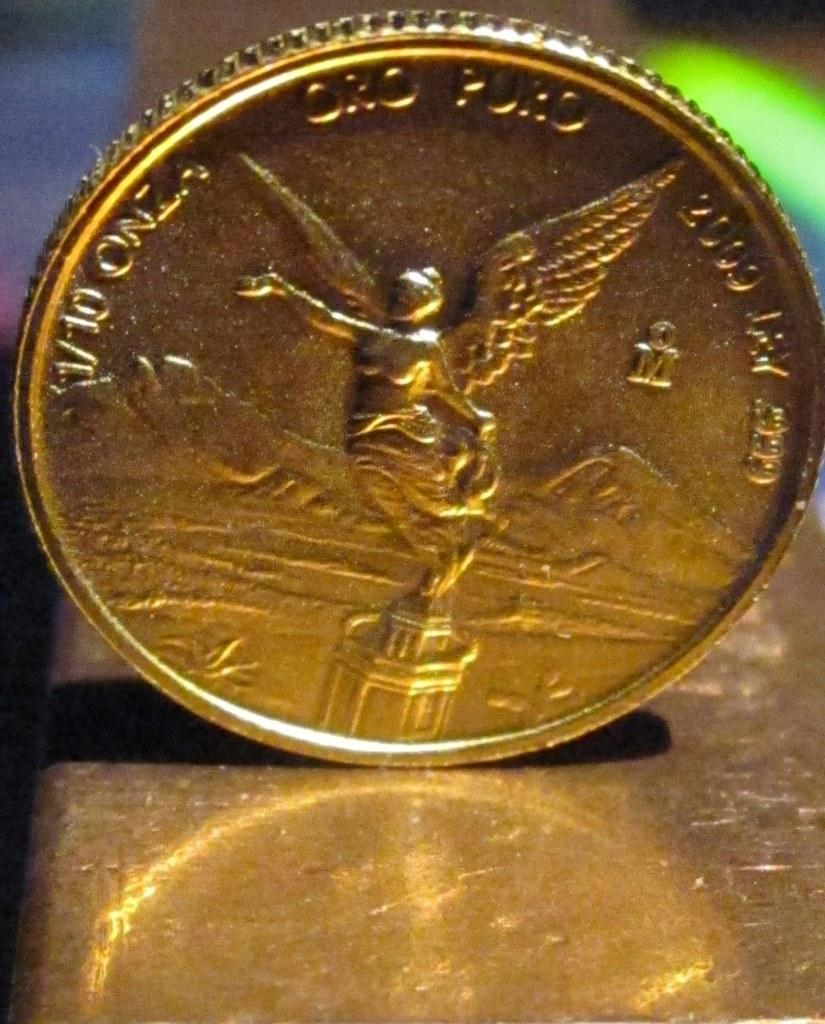<image>
Share a concise interpretation of the image provided. a gold coin with the number 2000 on it 